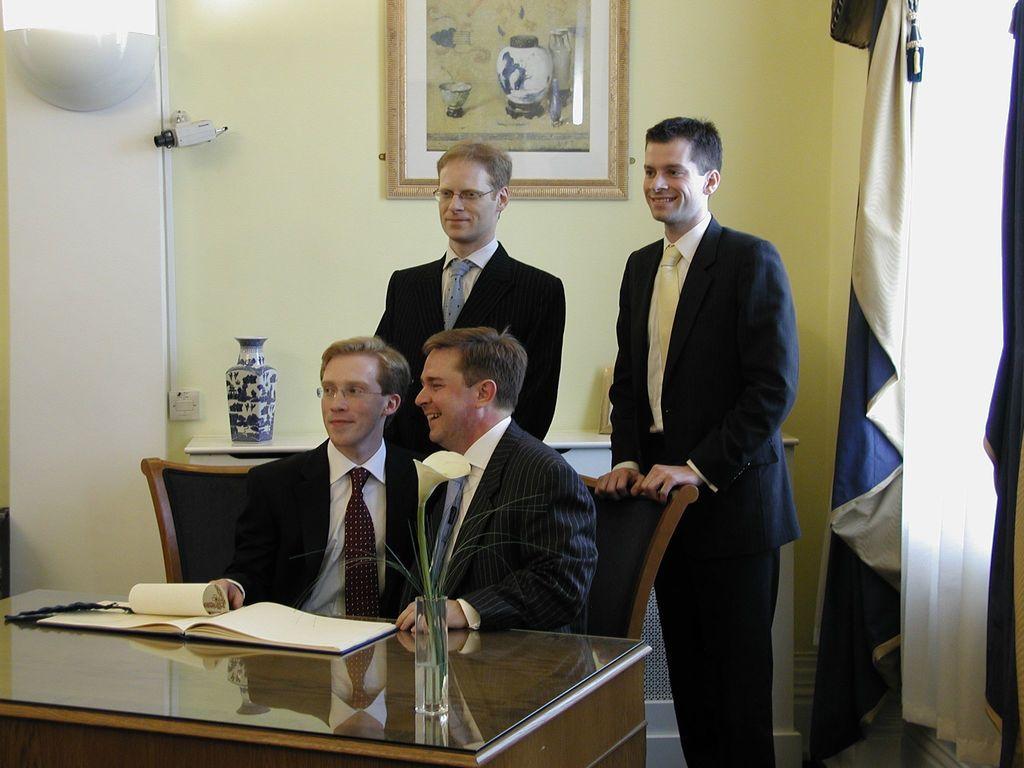Describe this image in one or two sentences. In this picture we can see four people two people are seated on the chair and two people are standing, in front of them we can find a flower vase books on the table, in the background we can see wall painting, curtains and a camera. 